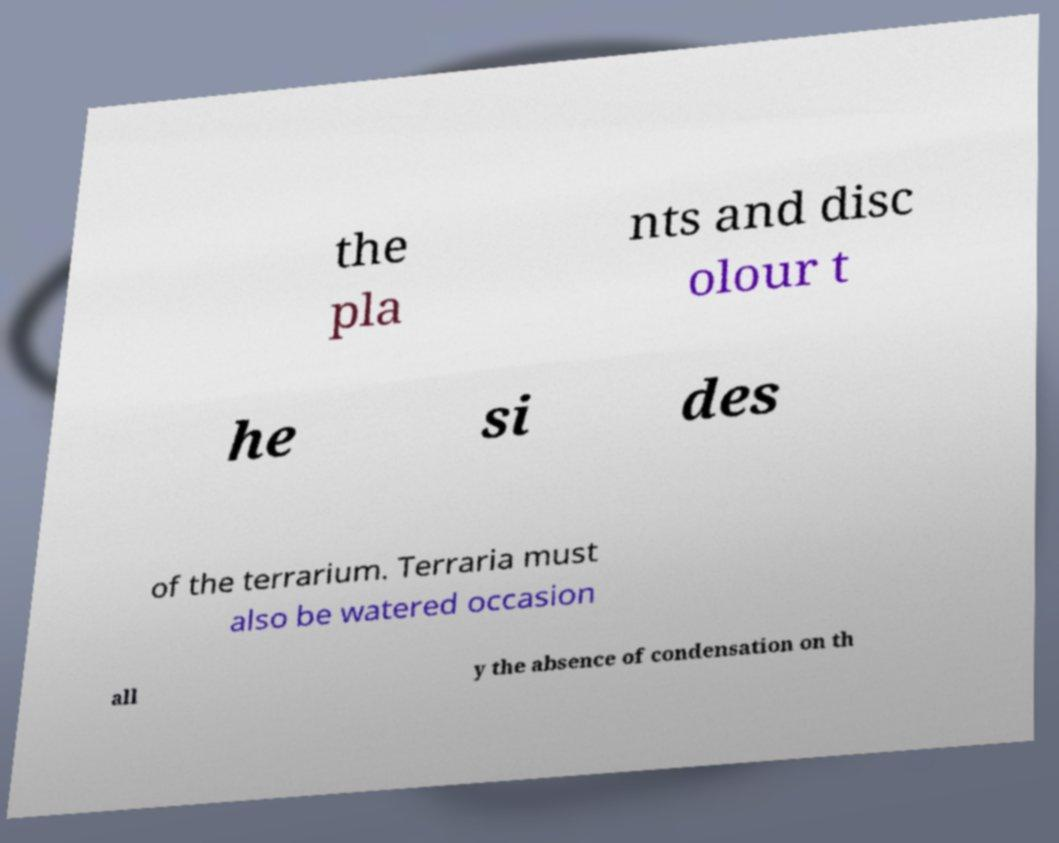There's text embedded in this image that I need extracted. Can you transcribe it verbatim? the pla nts and disc olour t he si des of the terrarium. Terraria must also be watered occasion all y the absence of condensation on th 